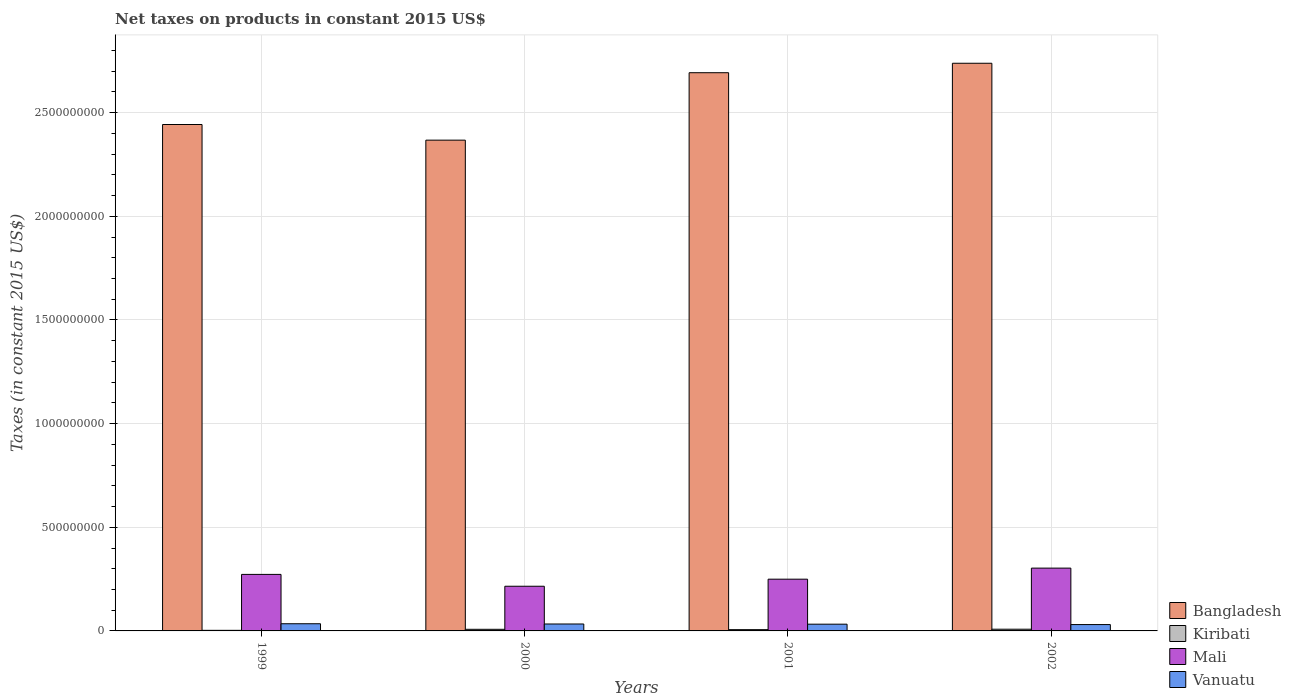How many groups of bars are there?
Offer a very short reply. 4. Are the number of bars on each tick of the X-axis equal?
Your response must be concise. Yes. How many bars are there on the 2nd tick from the left?
Make the answer very short. 4. In how many cases, is the number of bars for a given year not equal to the number of legend labels?
Give a very brief answer. 0. What is the net taxes on products in Bangladesh in 2002?
Make the answer very short. 2.74e+09. Across all years, what is the maximum net taxes on products in Mali?
Offer a very short reply. 3.03e+08. Across all years, what is the minimum net taxes on products in Kiribati?
Your answer should be compact. 2.83e+06. In which year was the net taxes on products in Mali maximum?
Ensure brevity in your answer.  2002. What is the total net taxes on products in Kiribati in the graph?
Make the answer very short. 2.50e+07. What is the difference between the net taxes on products in Vanuatu in 1999 and that in 2000?
Give a very brief answer. 1.22e+06. What is the difference between the net taxes on products in Vanuatu in 2000 and the net taxes on products in Bangladesh in 1999?
Keep it short and to the point. -2.41e+09. What is the average net taxes on products in Kiribati per year?
Your answer should be compact. 6.26e+06. In the year 2000, what is the difference between the net taxes on products in Mali and net taxes on products in Vanuatu?
Keep it short and to the point. 1.82e+08. What is the ratio of the net taxes on products in Bangladesh in 1999 to that in 2001?
Your answer should be very brief. 0.91. Is the difference between the net taxes on products in Mali in 1999 and 2001 greater than the difference between the net taxes on products in Vanuatu in 1999 and 2001?
Make the answer very short. Yes. What is the difference between the highest and the second highest net taxes on products in Kiribati?
Ensure brevity in your answer.  4.34e+05. What is the difference between the highest and the lowest net taxes on products in Mali?
Provide a succinct answer. 8.74e+07. What does the 4th bar from the left in 2002 represents?
Offer a very short reply. Vanuatu. What does the 3rd bar from the right in 2001 represents?
Offer a very short reply. Kiribati. How many bars are there?
Provide a short and direct response. 16. How many years are there in the graph?
Provide a succinct answer. 4. What is the difference between two consecutive major ticks on the Y-axis?
Offer a very short reply. 5.00e+08. Does the graph contain grids?
Your answer should be very brief. Yes. Where does the legend appear in the graph?
Your answer should be compact. Bottom right. What is the title of the graph?
Your answer should be very brief. Net taxes on products in constant 2015 US$. Does "Cuba" appear as one of the legend labels in the graph?
Offer a very short reply. No. What is the label or title of the Y-axis?
Provide a short and direct response. Taxes (in constant 2015 US$). What is the Taxes (in constant 2015 US$) of Bangladesh in 1999?
Your response must be concise. 2.44e+09. What is the Taxes (in constant 2015 US$) of Kiribati in 1999?
Make the answer very short. 2.83e+06. What is the Taxes (in constant 2015 US$) of Mali in 1999?
Provide a succinct answer. 2.73e+08. What is the Taxes (in constant 2015 US$) in Vanuatu in 1999?
Your answer should be very brief. 3.46e+07. What is the Taxes (in constant 2015 US$) of Bangladesh in 2000?
Your answer should be very brief. 2.37e+09. What is the Taxes (in constant 2015 US$) of Kiribati in 2000?
Ensure brevity in your answer.  7.83e+06. What is the Taxes (in constant 2015 US$) of Mali in 2000?
Make the answer very short. 2.16e+08. What is the Taxes (in constant 2015 US$) in Vanuatu in 2000?
Ensure brevity in your answer.  3.34e+07. What is the Taxes (in constant 2015 US$) in Bangladesh in 2001?
Your answer should be compact. 2.69e+09. What is the Taxes (in constant 2015 US$) of Kiribati in 2001?
Your answer should be very brief. 6.11e+06. What is the Taxes (in constant 2015 US$) in Mali in 2001?
Your response must be concise. 2.50e+08. What is the Taxes (in constant 2015 US$) of Vanuatu in 2001?
Your response must be concise. 3.25e+07. What is the Taxes (in constant 2015 US$) of Bangladesh in 2002?
Make the answer very short. 2.74e+09. What is the Taxes (in constant 2015 US$) in Kiribati in 2002?
Ensure brevity in your answer.  8.26e+06. What is the Taxes (in constant 2015 US$) of Mali in 2002?
Your response must be concise. 3.03e+08. What is the Taxes (in constant 2015 US$) in Vanuatu in 2002?
Your response must be concise. 3.06e+07. Across all years, what is the maximum Taxes (in constant 2015 US$) in Bangladesh?
Provide a succinct answer. 2.74e+09. Across all years, what is the maximum Taxes (in constant 2015 US$) in Kiribati?
Your answer should be compact. 8.26e+06. Across all years, what is the maximum Taxes (in constant 2015 US$) in Mali?
Your answer should be very brief. 3.03e+08. Across all years, what is the maximum Taxes (in constant 2015 US$) in Vanuatu?
Your response must be concise. 3.46e+07. Across all years, what is the minimum Taxes (in constant 2015 US$) of Bangladesh?
Keep it short and to the point. 2.37e+09. Across all years, what is the minimum Taxes (in constant 2015 US$) in Kiribati?
Your answer should be compact. 2.83e+06. Across all years, what is the minimum Taxes (in constant 2015 US$) of Mali?
Offer a very short reply. 2.16e+08. Across all years, what is the minimum Taxes (in constant 2015 US$) of Vanuatu?
Your answer should be very brief. 3.06e+07. What is the total Taxes (in constant 2015 US$) of Bangladesh in the graph?
Provide a short and direct response. 1.02e+1. What is the total Taxes (in constant 2015 US$) of Kiribati in the graph?
Your answer should be very brief. 2.50e+07. What is the total Taxes (in constant 2015 US$) of Mali in the graph?
Keep it short and to the point. 1.04e+09. What is the total Taxes (in constant 2015 US$) of Vanuatu in the graph?
Provide a succinct answer. 1.31e+08. What is the difference between the Taxes (in constant 2015 US$) in Bangladesh in 1999 and that in 2000?
Offer a terse response. 7.55e+07. What is the difference between the Taxes (in constant 2015 US$) in Kiribati in 1999 and that in 2000?
Give a very brief answer. -5.00e+06. What is the difference between the Taxes (in constant 2015 US$) of Mali in 1999 and that in 2000?
Give a very brief answer. 5.72e+07. What is the difference between the Taxes (in constant 2015 US$) of Vanuatu in 1999 and that in 2000?
Your response must be concise. 1.22e+06. What is the difference between the Taxes (in constant 2015 US$) of Bangladesh in 1999 and that in 2001?
Offer a terse response. -2.50e+08. What is the difference between the Taxes (in constant 2015 US$) of Kiribati in 1999 and that in 2001?
Give a very brief answer. -3.28e+06. What is the difference between the Taxes (in constant 2015 US$) in Mali in 1999 and that in 2001?
Provide a succinct answer. 2.31e+07. What is the difference between the Taxes (in constant 2015 US$) in Vanuatu in 1999 and that in 2001?
Offer a terse response. 2.12e+06. What is the difference between the Taxes (in constant 2015 US$) in Bangladesh in 1999 and that in 2002?
Make the answer very short. -2.95e+08. What is the difference between the Taxes (in constant 2015 US$) in Kiribati in 1999 and that in 2002?
Your answer should be very brief. -5.44e+06. What is the difference between the Taxes (in constant 2015 US$) in Mali in 1999 and that in 2002?
Offer a terse response. -3.03e+07. What is the difference between the Taxes (in constant 2015 US$) in Vanuatu in 1999 and that in 2002?
Provide a succinct answer. 4.02e+06. What is the difference between the Taxes (in constant 2015 US$) in Bangladesh in 2000 and that in 2001?
Your response must be concise. -3.25e+08. What is the difference between the Taxes (in constant 2015 US$) in Kiribati in 2000 and that in 2001?
Give a very brief answer. 1.73e+06. What is the difference between the Taxes (in constant 2015 US$) in Mali in 2000 and that in 2001?
Your answer should be compact. -3.41e+07. What is the difference between the Taxes (in constant 2015 US$) of Vanuatu in 2000 and that in 2001?
Make the answer very short. 8.97e+05. What is the difference between the Taxes (in constant 2015 US$) of Bangladesh in 2000 and that in 2002?
Your answer should be compact. -3.71e+08. What is the difference between the Taxes (in constant 2015 US$) in Kiribati in 2000 and that in 2002?
Give a very brief answer. -4.34e+05. What is the difference between the Taxes (in constant 2015 US$) of Mali in 2000 and that in 2002?
Provide a succinct answer. -8.74e+07. What is the difference between the Taxes (in constant 2015 US$) of Vanuatu in 2000 and that in 2002?
Your response must be concise. 2.80e+06. What is the difference between the Taxes (in constant 2015 US$) in Bangladesh in 2001 and that in 2002?
Offer a very short reply. -4.56e+07. What is the difference between the Taxes (in constant 2015 US$) of Kiribati in 2001 and that in 2002?
Provide a short and direct response. -2.16e+06. What is the difference between the Taxes (in constant 2015 US$) in Mali in 2001 and that in 2002?
Your answer should be very brief. -5.34e+07. What is the difference between the Taxes (in constant 2015 US$) of Vanuatu in 2001 and that in 2002?
Ensure brevity in your answer.  1.90e+06. What is the difference between the Taxes (in constant 2015 US$) of Bangladesh in 1999 and the Taxes (in constant 2015 US$) of Kiribati in 2000?
Offer a very short reply. 2.44e+09. What is the difference between the Taxes (in constant 2015 US$) of Bangladesh in 1999 and the Taxes (in constant 2015 US$) of Mali in 2000?
Offer a very short reply. 2.23e+09. What is the difference between the Taxes (in constant 2015 US$) in Bangladesh in 1999 and the Taxes (in constant 2015 US$) in Vanuatu in 2000?
Your response must be concise. 2.41e+09. What is the difference between the Taxes (in constant 2015 US$) in Kiribati in 1999 and the Taxes (in constant 2015 US$) in Mali in 2000?
Provide a short and direct response. -2.13e+08. What is the difference between the Taxes (in constant 2015 US$) in Kiribati in 1999 and the Taxes (in constant 2015 US$) in Vanuatu in 2000?
Keep it short and to the point. -3.06e+07. What is the difference between the Taxes (in constant 2015 US$) in Mali in 1999 and the Taxes (in constant 2015 US$) in Vanuatu in 2000?
Your response must be concise. 2.39e+08. What is the difference between the Taxes (in constant 2015 US$) of Bangladesh in 1999 and the Taxes (in constant 2015 US$) of Kiribati in 2001?
Your answer should be compact. 2.44e+09. What is the difference between the Taxes (in constant 2015 US$) in Bangladesh in 1999 and the Taxes (in constant 2015 US$) in Mali in 2001?
Ensure brevity in your answer.  2.19e+09. What is the difference between the Taxes (in constant 2015 US$) of Bangladesh in 1999 and the Taxes (in constant 2015 US$) of Vanuatu in 2001?
Offer a very short reply. 2.41e+09. What is the difference between the Taxes (in constant 2015 US$) of Kiribati in 1999 and the Taxes (in constant 2015 US$) of Mali in 2001?
Give a very brief answer. -2.47e+08. What is the difference between the Taxes (in constant 2015 US$) of Kiribati in 1999 and the Taxes (in constant 2015 US$) of Vanuatu in 2001?
Keep it short and to the point. -2.97e+07. What is the difference between the Taxes (in constant 2015 US$) of Mali in 1999 and the Taxes (in constant 2015 US$) of Vanuatu in 2001?
Keep it short and to the point. 2.40e+08. What is the difference between the Taxes (in constant 2015 US$) of Bangladesh in 1999 and the Taxes (in constant 2015 US$) of Kiribati in 2002?
Make the answer very short. 2.43e+09. What is the difference between the Taxes (in constant 2015 US$) in Bangladesh in 1999 and the Taxes (in constant 2015 US$) in Mali in 2002?
Provide a short and direct response. 2.14e+09. What is the difference between the Taxes (in constant 2015 US$) in Bangladesh in 1999 and the Taxes (in constant 2015 US$) in Vanuatu in 2002?
Give a very brief answer. 2.41e+09. What is the difference between the Taxes (in constant 2015 US$) of Kiribati in 1999 and the Taxes (in constant 2015 US$) of Mali in 2002?
Ensure brevity in your answer.  -3.00e+08. What is the difference between the Taxes (in constant 2015 US$) in Kiribati in 1999 and the Taxes (in constant 2015 US$) in Vanuatu in 2002?
Make the answer very short. -2.78e+07. What is the difference between the Taxes (in constant 2015 US$) in Mali in 1999 and the Taxes (in constant 2015 US$) in Vanuatu in 2002?
Provide a short and direct response. 2.42e+08. What is the difference between the Taxes (in constant 2015 US$) in Bangladesh in 2000 and the Taxes (in constant 2015 US$) in Kiribati in 2001?
Provide a succinct answer. 2.36e+09. What is the difference between the Taxes (in constant 2015 US$) in Bangladesh in 2000 and the Taxes (in constant 2015 US$) in Mali in 2001?
Offer a terse response. 2.12e+09. What is the difference between the Taxes (in constant 2015 US$) in Bangladesh in 2000 and the Taxes (in constant 2015 US$) in Vanuatu in 2001?
Offer a terse response. 2.34e+09. What is the difference between the Taxes (in constant 2015 US$) of Kiribati in 2000 and the Taxes (in constant 2015 US$) of Mali in 2001?
Give a very brief answer. -2.42e+08. What is the difference between the Taxes (in constant 2015 US$) of Kiribati in 2000 and the Taxes (in constant 2015 US$) of Vanuatu in 2001?
Your answer should be compact. -2.47e+07. What is the difference between the Taxes (in constant 2015 US$) of Mali in 2000 and the Taxes (in constant 2015 US$) of Vanuatu in 2001?
Offer a very short reply. 1.83e+08. What is the difference between the Taxes (in constant 2015 US$) in Bangladesh in 2000 and the Taxes (in constant 2015 US$) in Kiribati in 2002?
Offer a very short reply. 2.36e+09. What is the difference between the Taxes (in constant 2015 US$) of Bangladesh in 2000 and the Taxes (in constant 2015 US$) of Mali in 2002?
Your answer should be compact. 2.06e+09. What is the difference between the Taxes (in constant 2015 US$) in Bangladesh in 2000 and the Taxes (in constant 2015 US$) in Vanuatu in 2002?
Make the answer very short. 2.34e+09. What is the difference between the Taxes (in constant 2015 US$) of Kiribati in 2000 and the Taxes (in constant 2015 US$) of Mali in 2002?
Give a very brief answer. -2.95e+08. What is the difference between the Taxes (in constant 2015 US$) of Kiribati in 2000 and the Taxes (in constant 2015 US$) of Vanuatu in 2002?
Your answer should be very brief. -2.28e+07. What is the difference between the Taxes (in constant 2015 US$) in Mali in 2000 and the Taxes (in constant 2015 US$) in Vanuatu in 2002?
Your answer should be very brief. 1.85e+08. What is the difference between the Taxes (in constant 2015 US$) of Bangladesh in 2001 and the Taxes (in constant 2015 US$) of Kiribati in 2002?
Your answer should be compact. 2.68e+09. What is the difference between the Taxes (in constant 2015 US$) of Bangladesh in 2001 and the Taxes (in constant 2015 US$) of Mali in 2002?
Keep it short and to the point. 2.39e+09. What is the difference between the Taxes (in constant 2015 US$) in Bangladesh in 2001 and the Taxes (in constant 2015 US$) in Vanuatu in 2002?
Provide a short and direct response. 2.66e+09. What is the difference between the Taxes (in constant 2015 US$) in Kiribati in 2001 and the Taxes (in constant 2015 US$) in Mali in 2002?
Your answer should be compact. -2.97e+08. What is the difference between the Taxes (in constant 2015 US$) of Kiribati in 2001 and the Taxes (in constant 2015 US$) of Vanuatu in 2002?
Give a very brief answer. -2.45e+07. What is the difference between the Taxes (in constant 2015 US$) in Mali in 2001 and the Taxes (in constant 2015 US$) in Vanuatu in 2002?
Ensure brevity in your answer.  2.19e+08. What is the average Taxes (in constant 2015 US$) in Bangladesh per year?
Keep it short and to the point. 2.56e+09. What is the average Taxes (in constant 2015 US$) in Kiribati per year?
Your answer should be compact. 6.26e+06. What is the average Taxes (in constant 2015 US$) of Mali per year?
Ensure brevity in your answer.  2.60e+08. What is the average Taxes (in constant 2015 US$) in Vanuatu per year?
Your answer should be very brief. 3.28e+07. In the year 1999, what is the difference between the Taxes (in constant 2015 US$) in Bangladesh and Taxes (in constant 2015 US$) in Kiribati?
Give a very brief answer. 2.44e+09. In the year 1999, what is the difference between the Taxes (in constant 2015 US$) of Bangladesh and Taxes (in constant 2015 US$) of Mali?
Provide a short and direct response. 2.17e+09. In the year 1999, what is the difference between the Taxes (in constant 2015 US$) in Bangladesh and Taxes (in constant 2015 US$) in Vanuatu?
Give a very brief answer. 2.41e+09. In the year 1999, what is the difference between the Taxes (in constant 2015 US$) in Kiribati and Taxes (in constant 2015 US$) in Mali?
Ensure brevity in your answer.  -2.70e+08. In the year 1999, what is the difference between the Taxes (in constant 2015 US$) in Kiribati and Taxes (in constant 2015 US$) in Vanuatu?
Make the answer very short. -3.18e+07. In the year 1999, what is the difference between the Taxes (in constant 2015 US$) in Mali and Taxes (in constant 2015 US$) in Vanuatu?
Make the answer very short. 2.38e+08. In the year 2000, what is the difference between the Taxes (in constant 2015 US$) in Bangladesh and Taxes (in constant 2015 US$) in Kiribati?
Offer a very short reply. 2.36e+09. In the year 2000, what is the difference between the Taxes (in constant 2015 US$) of Bangladesh and Taxes (in constant 2015 US$) of Mali?
Keep it short and to the point. 2.15e+09. In the year 2000, what is the difference between the Taxes (in constant 2015 US$) of Bangladesh and Taxes (in constant 2015 US$) of Vanuatu?
Provide a short and direct response. 2.33e+09. In the year 2000, what is the difference between the Taxes (in constant 2015 US$) of Kiribati and Taxes (in constant 2015 US$) of Mali?
Keep it short and to the point. -2.08e+08. In the year 2000, what is the difference between the Taxes (in constant 2015 US$) of Kiribati and Taxes (in constant 2015 US$) of Vanuatu?
Offer a terse response. -2.56e+07. In the year 2000, what is the difference between the Taxes (in constant 2015 US$) in Mali and Taxes (in constant 2015 US$) in Vanuatu?
Give a very brief answer. 1.82e+08. In the year 2001, what is the difference between the Taxes (in constant 2015 US$) of Bangladesh and Taxes (in constant 2015 US$) of Kiribati?
Give a very brief answer. 2.69e+09. In the year 2001, what is the difference between the Taxes (in constant 2015 US$) of Bangladesh and Taxes (in constant 2015 US$) of Mali?
Give a very brief answer. 2.44e+09. In the year 2001, what is the difference between the Taxes (in constant 2015 US$) of Bangladesh and Taxes (in constant 2015 US$) of Vanuatu?
Provide a succinct answer. 2.66e+09. In the year 2001, what is the difference between the Taxes (in constant 2015 US$) in Kiribati and Taxes (in constant 2015 US$) in Mali?
Your answer should be very brief. -2.43e+08. In the year 2001, what is the difference between the Taxes (in constant 2015 US$) in Kiribati and Taxes (in constant 2015 US$) in Vanuatu?
Provide a short and direct response. -2.64e+07. In the year 2001, what is the difference between the Taxes (in constant 2015 US$) of Mali and Taxes (in constant 2015 US$) of Vanuatu?
Your answer should be compact. 2.17e+08. In the year 2002, what is the difference between the Taxes (in constant 2015 US$) in Bangladesh and Taxes (in constant 2015 US$) in Kiribati?
Provide a succinct answer. 2.73e+09. In the year 2002, what is the difference between the Taxes (in constant 2015 US$) in Bangladesh and Taxes (in constant 2015 US$) in Mali?
Ensure brevity in your answer.  2.44e+09. In the year 2002, what is the difference between the Taxes (in constant 2015 US$) in Bangladesh and Taxes (in constant 2015 US$) in Vanuatu?
Provide a succinct answer. 2.71e+09. In the year 2002, what is the difference between the Taxes (in constant 2015 US$) in Kiribati and Taxes (in constant 2015 US$) in Mali?
Your response must be concise. -2.95e+08. In the year 2002, what is the difference between the Taxes (in constant 2015 US$) of Kiribati and Taxes (in constant 2015 US$) of Vanuatu?
Offer a very short reply. -2.24e+07. In the year 2002, what is the difference between the Taxes (in constant 2015 US$) of Mali and Taxes (in constant 2015 US$) of Vanuatu?
Your response must be concise. 2.72e+08. What is the ratio of the Taxes (in constant 2015 US$) in Bangladesh in 1999 to that in 2000?
Provide a succinct answer. 1.03. What is the ratio of the Taxes (in constant 2015 US$) of Kiribati in 1999 to that in 2000?
Keep it short and to the point. 0.36. What is the ratio of the Taxes (in constant 2015 US$) in Mali in 1999 to that in 2000?
Provide a succinct answer. 1.27. What is the ratio of the Taxes (in constant 2015 US$) of Vanuatu in 1999 to that in 2000?
Provide a short and direct response. 1.04. What is the ratio of the Taxes (in constant 2015 US$) in Bangladesh in 1999 to that in 2001?
Ensure brevity in your answer.  0.91. What is the ratio of the Taxes (in constant 2015 US$) in Kiribati in 1999 to that in 2001?
Your response must be concise. 0.46. What is the ratio of the Taxes (in constant 2015 US$) in Mali in 1999 to that in 2001?
Your response must be concise. 1.09. What is the ratio of the Taxes (in constant 2015 US$) in Vanuatu in 1999 to that in 2001?
Give a very brief answer. 1.07. What is the ratio of the Taxes (in constant 2015 US$) in Bangladesh in 1999 to that in 2002?
Keep it short and to the point. 0.89. What is the ratio of the Taxes (in constant 2015 US$) in Kiribati in 1999 to that in 2002?
Ensure brevity in your answer.  0.34. What is the ratio of the Taxes (in constant 2015 US$) in Mali in 1999 to that in 2002?
Provide a succinct answer. 0.9. What is the ratio of the Taxes (in constant 2015 US$) of Vanuatu in 1999 to that in 2002?
Your response must be concise. 1.13. What is the ratio of the Taxes (in constant 2015 US$) of Bangladesh in 2000 to that in 2001?
Offer a terse response. 0.88. What is the ratio of the Taxes (in constant 2015 US$) in Kiribati in 2000 to that in 2001?
Make the answer very short. 1.28. What is the ratio of the Taxes (in constant 2015 US$) in Mali in 2000 to that in 2001?
Keep it short and to the point. 0.86. What is the ratio of the Taxes (in constant 2015 US$) in Vanuatu in 2000 to that in 2001?
Provide a succinct answer. 1.03. What is the ratio of the Taxes (in constant 2015 US$) in Bangladesh in 2000 to that in 2002?
Keep it short and to the point. 0.86. What is the ratio of the Taxes (in constant 2015 US$) in Kiribati in 2000 to that in 2002?
Ensure brevity in your answer.  0.95. What is the ratio of the Taxes (in constant 2015 US$) in Mali in 2000 to that in 2002?
Make the answer very short. 0.71. What is the ratio of the Taxes (in constant 2015 US$) in Vanuatu in 2000 to that in 2002?
Keep it short and to the point. 1.09. What is the ratio of the Taxes (in constant 2015 US$) in Bangladesh in 2001 to that in 2002?
Offer a terse response. 0.98. What is the ratio of the Taxes (in constant 2015 US$) of Kiribati in 2001 to that in 2002?
Offer a terse response. 0.74. What is the ratio of the Taxes (in constant 2015 US$) in Mali in 2001 to that in 2002?
Provide a succinct answer. 0.82. What is the ratio of the Taxes (in constant 2015 US$) in Vanuatu in 2001 to that in 2002?
Keep it short and to the point. 1.06. What is the difference between the highest and the second highest Taxes (in constant 2015 US$) of Bangladesh?
Give a very brief answer. 4.56e+07. What is the difference between the highest and the second highest Taxes (in constant 2015 US$) in Kiribati?
Your response must be concise. 4.34e+05. What is the difference between the highest and the second highest Taxes (in constant 2015 US$) of Mali?
Make the answer very short. 3.03e+07. What is the difference between the highest and the second highest Taxes (in constant 2015 US$) of Vanuatu?
Provide a short and direct response. 1.22e+06. What is the difference between the highest and the lowest Taxes (in constant 2015 US$) of Bangladesh?
Make the answer very short. 3.71e+08. What is the difference between the highest and the lowest Taxes (in constant 2015 US$) of Kiribati?
Keep it short and to the point. 5.44e+06. What is the difference between the highest and the lowest Taxes (in constant 2015 US$) in Mali?
Ensure brevity in your answer.  8.74e+07. What is the difference between the highest and the lowest Taxes (in constant 2015 US$) of Vanuatu?
Ensure brevity in your answer.  4.02e+06. 